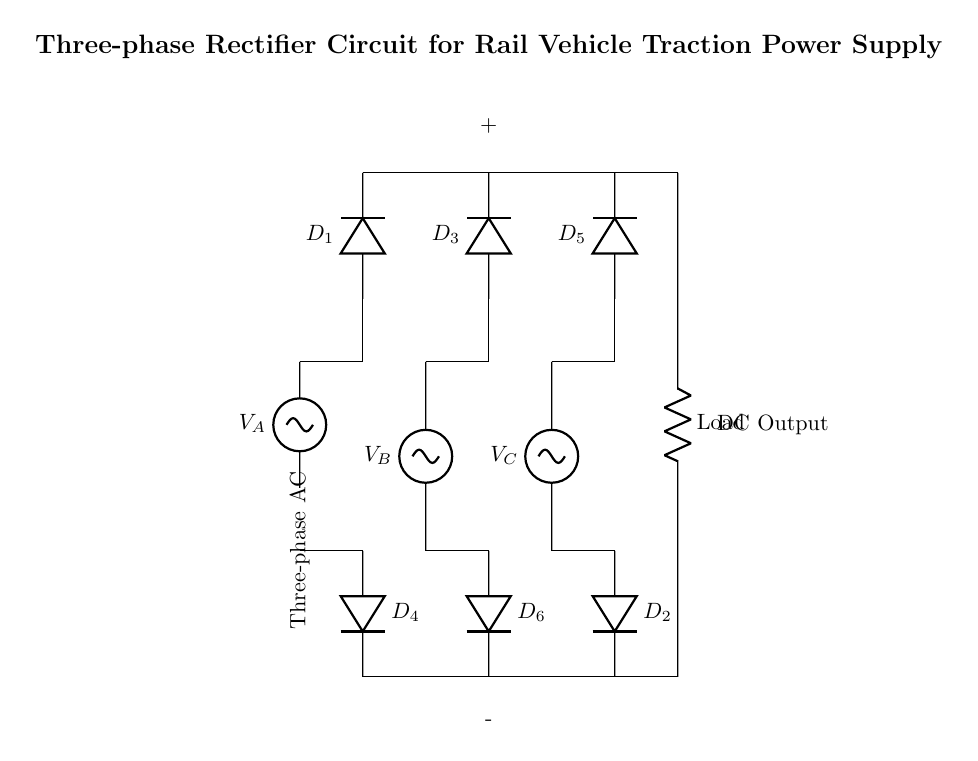What type of circuit is represented in the diagram? The diagram shows a three-phase rectifier circuit. The title explicitly states that it is a "Three-phase Rectifier Circuit for Rail Vehicle Traction Power Supply," indicating the type of circuit.
Answer: Three-phase rectifier How many diodes are used in this circuit? Counting the diodes in the diagram, there are six labeled as D1, D2, D3, D4, D5, and D6.
Answer: Six What is the function of the load resistor in this circuit? The load resistor converts the DC output into usable power for traction systems, providing the necessary current and voltage.
Answer: Converts DC output Which diodes conduct during the positive cycle of the input voltage? During the positive cycle, diodes D1, D3, and D5 conduct. This is determined by analyzing the configuration of the diodes and the connections to the AC phases.
Answer: D1, D3, D5 What is the output type of this rectifier circuit? The output type is direct current. A rectifier circuit transforms alternating current from the AC source into a constant voltage and current DC output.
Answer: Direct current How does the three-phase configuration benefit the rectifier circuit? The three-phase configuration provides a smoother and more stable output voltage compared to single-phase systems, minimizing ripple and improving efficiency.
Answer: Smoother output What are the labels for the output terminals of the DC circuit? The output terminals are labeled as positive and negative, indicated by the symbols "+" and "-" located at the output connections of the load.
Answer: Positive and negative 